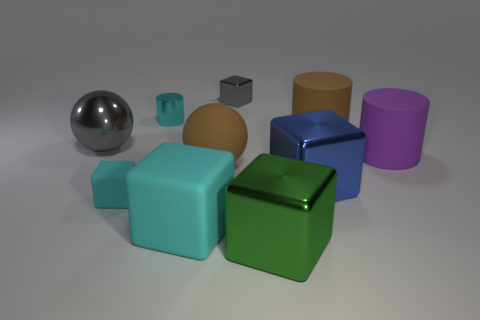Subtract 1 blocks. How many blocks are left? 4 Subtract all gray cubes. How many cubes are left? 4 Subtract all tiny shiny cubes. How many cubes are left? 4 Subtract all yellow blocks. Subtract all blue spheres. How many blocks are left? 5 Subtract all balls. How many objects are left? 8 Subtract all big brown spheres. Subtract all rubber objects. How many objects are left? 4 Add 1 tiny gray things. How many tiny gray things are left? 2 Add 1 large blocks. How many large blocks exist? 4 Subtract 0 yellow blocks. How many objects are left? 10 